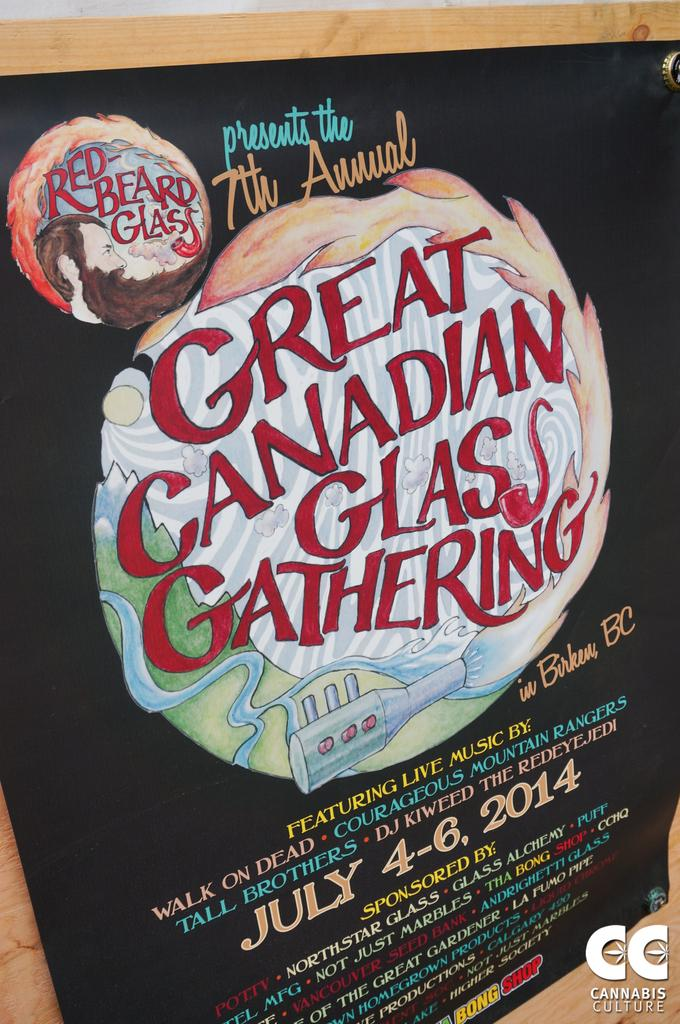What is the main object in the image? There is a blackboard in the image. What is on the blackboard? There is text written on the blackboard. What country is the robin from in the image? There is no robin present in the image; it only features a blackboard with text. 